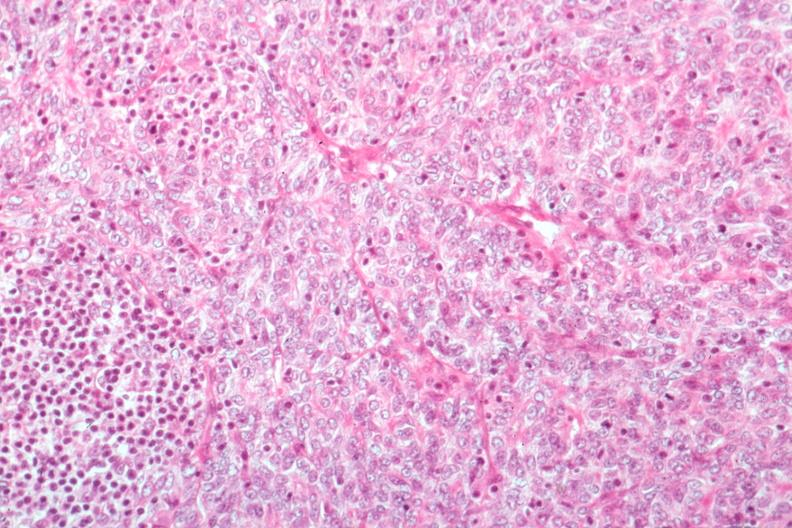what is present?
Answer the question using a single word or phrase. Hematologic 